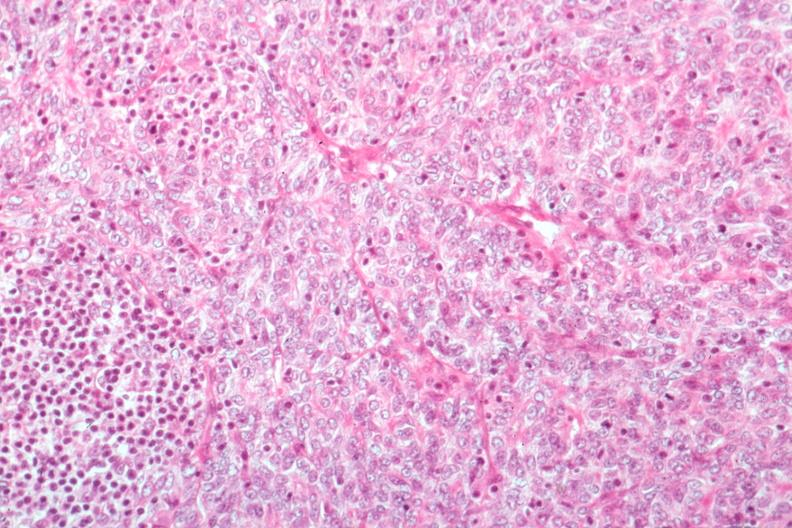what is present?
Answer the question using a single word or phrase. Hematologic 